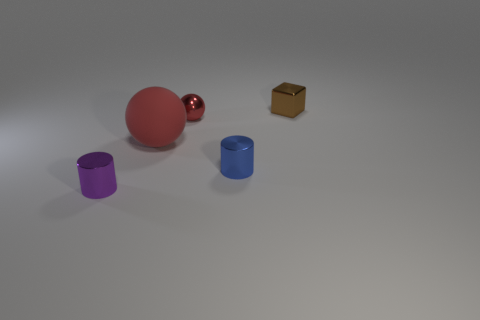Add 4 red objects. How many objects exist? 9 Subtract all blue cylinders. How many cylinders are left? 1 Subtract all cubes. How many objects are left? 4 Add 4 large objects. How many large objects exist? 5 Subtract 0 red blocks. How many objects are left? 5 Subtract all yellow cylinders. Subtract all gray cubes. How many cylinders are left? 2 Subtract all tiny metallic cylinders. Subtract all tiny red metal objects. How many objects are left? 2 Add 2 balls. How many balls are left? 4 